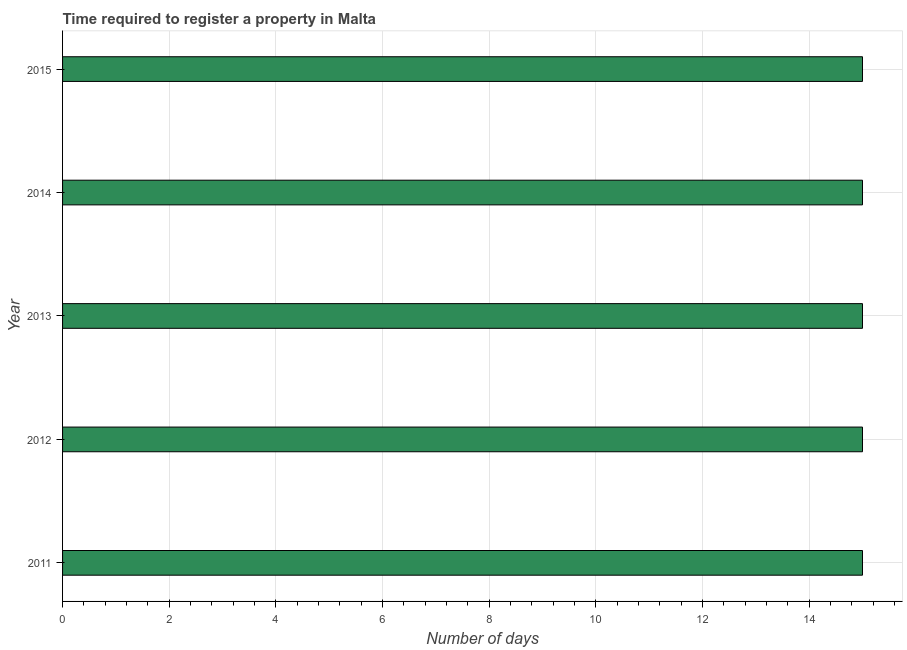Does the graph contain any zero values?
Your answer should be compact. No. What is the title of the graph?
Ensure brevity in your answer.  Time required to register a property in Malta. What is the label or title of the X-axis?
Your answer should be compact. Number of days. What is the label or title of the Y-axis?
Offer a very short reply. Year. Across all years, what is the maximum number of days required to register property?
Offer a terse response. 15. In which year was the number of days required to register property maximum?
Give a very brief answer. 2011. In which year was the number of days required to register property minimum?
Offer a terse response. 2011. What is the difference between the number of days required to register property in 2012 and 2014?
Provide a short and direct response. 0. In how many years, is the number of days required to register property greater than 8 days?
Provide a succinct answer. 5. Is the difference between the number of days required to register property in 2013 and 2015 greater than the difference between any two years?
Ensure brevity in your answer.  Yes. What is the difference between the highest and the second highest number of days required to register property?
Provide a short and direct response. 0. What is the difference between the highest and the lowest number of days required to register property?
Give a very brief answer. 0. In how many years, is the number of days required to register property greater than the average number of days required to register property taken over all years?
Offer a terse response. 0. How many bars are there?
Give a very brief answer. 5. Are all the bars in the graph horizontal?
Provide a short and direct response. Yes. How many years are there in the graph?
Make the answer very short. 5. What is the difference between two consecutive major ticks on the X-axis?
Your response must be concise. 2. Are the values on the major ticks of X-axis written in scientific E-notation?
Make the answer very short. No. What is the Number of days in 2011?
Your answer should be compact. 15. What is the Number of days in 2014?
Give a very brief answer. 15. What is the Number of days of 2015?
Provide a succinct answer. 15. What is the difference between the Number of days in 2011 and 2014?
Your answer should be compact. 0. What is the difference between the Number of days in 2011 and 2015?
Your response must be concise. 0. What is the difference between the Number of days in 2012 and 2014?
Offer a terse response. 0. What is the difference between the Number of days in 2013 and 2014?
Make the answer very short. 0. What is the difference between the Number of days in 2013 and 2015?
Give a very brief answer. 0. What is the ratio of the Number of days in 2011 to that in 2013?
Your response must be concise. 1. What is the ratio of the Number of days in 2011 to that in 2015?
Your answer should be very brief. 1. What is the ratio of the Number of days in 2012 to that in 2013?
Offer a very short reply. 1. What is the ratio of the Number of days in 2012 to that in 2015?
Provide a short and direct response. 1. What is the ratio of the Number of days in 2013 to that in 2015?
Keep it short and to the point. 1. What is the ratio of the Number of days in 2014 to that in 2015?
Provide a succinct answer. 1. 